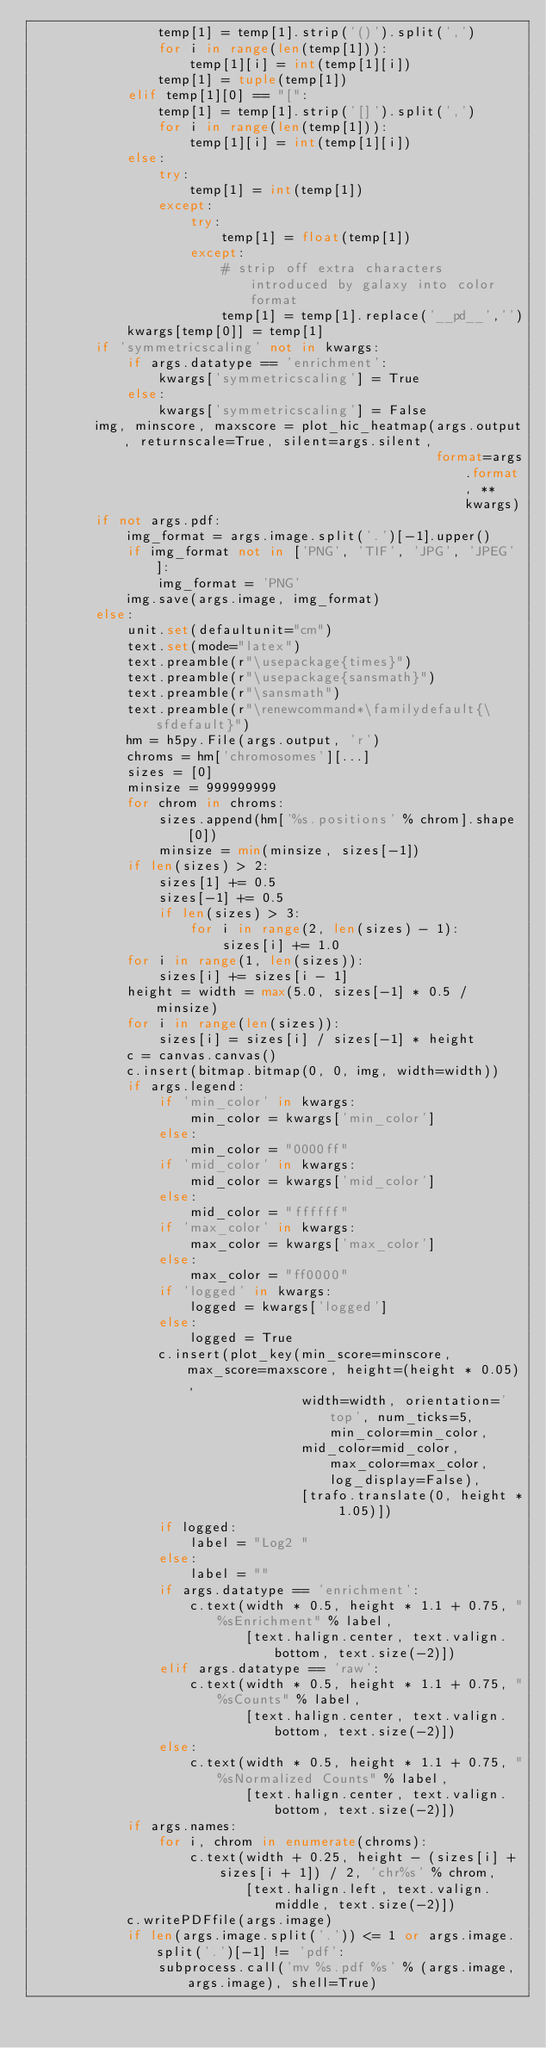<code> <loc_0><loc_0><loc_500><loc_500><_Python_>                temp[1] = temp[1].strip('()').split(',')
                for i in range(len(temp[1])):
                    temp[1][i] = int(temp[1][i])
                temp[1] = tuple(temp[1])
            elif temp[1][0] == "[":
                temp[1] = temp[1].strip('[]').split(',')
                for i in range(len(temp[1])):
                    temp[1][i] = int(temp[1][i])
            else:
                try:
                    temp[1] = int(temp[1])
                except:
                    try:
                        temp[1] = float(temp[1])
                    except:
                        # strip off extra characters introduced by galaxy into color format
                        temp[1] = temp[1].replace('__pd__','')
            kwargs[temp[0]] = temp[1]
        if 'symmetricscaling' not in kwargs:
            if args.datatype == 'enrichment':
                kwargs['symmetricscaling'] = True
            else:
                kwargs['symmetricscaling'] = False
        img, minscore, maxscore = plot_hic_heatmap(args.output, returnscale=True, silent=args.silent,
                                                   format=args.format, **kwargs)
        if not args.pdf:
            img_format = args.image.split('.')[-1].upper()
            if img_format not in ['PNG', 'TIF', 'JPG', 'JPEG']:
                img_format = 'PNG'
            img.save(args.image, img_format)
        else:
            unit.set(defaultunit="cm")
            text.set(mode="latex")
            text.preamble(r"\usepackage{times}")
            text.preamble(r"\usepackage{sansmath}")
            text.preamble(r"\sansmath")
            text.preamble(r"\renewcommand*\familydefault{\sfdefault}")
            hm = h5py.File(args.output, 'r')
            chroms = hm['chromosomes'][...]
            sizes = [0]
            minsize = 999999999
            for chrom in chroms:
                sizes.append(hm['%s.positions' % chrom].shape[0])
                minsize = min(minsize, sizes[-1])
            if len(sizes) > 2:
                sizes[1] += 0.5
                sizes[-1] += 0.5
                if len(sizes) > 3:
                    for i in range(2, len(sizes) - 1):
                        sizes[i] += 1.0
            for i in range(1, len(sizes)):
                sizes[i] += sizes[i - 1]
            height = width = max(5.0, sizes[-1] * 0.5 / minsize)
            for i in range(len(sizes)):
                sizes[i] = sizes[i] / sizes[-1] * height
            c = canvas.canvas()
            c.insert(bitmap.bitmap(0, 0, img, width=width))
            if args.legend:
                if 'min_color' in kwargs:
                    min_color = kwargs['min_color']
                else:
                    min_color = "0000ff"
                if 'mid_color' in kwargs:
                    mid_color = kwargs['mid_color']
                else:
                    mid_color = "ffffff"
                if 'max_color' in kwargs:
                    max_color = kwargs['max_color']
                else:
                    max_color = "ff0000"
                if 'logged' in kwargs:
                    logged = kwargs['logged']
                else:
                    logged = True
                c.insert(plot_key(min_score=minscore, max_score=maxscore, height=(height * 0.05),
                                  width=width, orientation='top', num_ticks=5, min_color=min_color,
                                  mid_color=mid_color, max_color=max_color, log_display=False),
                                  [trafo.translate(0, height * 1.05)])
                if logged:
                    label = "Log2 "
                else:
                    label = ""
                if args.datatype == 'enrichment':
                    c.text(width * 0.5, height * 1.1 + 0.75, "%sEnrichment" % label,
                           [text.halign.center, text.valign.bottom, text.size(-2)])
                elif args.datatype == 'raw':
                    c.text(width * 0.5, height * 1.1 + 0.75, "%sCounts" % label,
                           [text.halign.center, text.valign.bottom, text.size(-2)])
                else:
                    c.text(width * 0.5, height * 1.1 + 0.75, "%sNormalized Counts" % label,
                           [text.halign.center, text.valign.bottom, text.size(-2)])
            if args.names:
                for i, chrom in enumerate(chroms):
                    c.text(width + 0.25, height - (sizes[i] + sizes[i + 1]) / 2, 'chr%s' % chrom,
                           [text.halign.left, text.valign.middle, text.size(-2)])
            c.writePDFfile(args.image)
            if len(args.image.split('.')) <= 1 or args.image.split('.')[-1] != 'pdf':
                subprocess.call('mv %s.pdf %s' % (args.image, args.image), shell=True)
</code> 